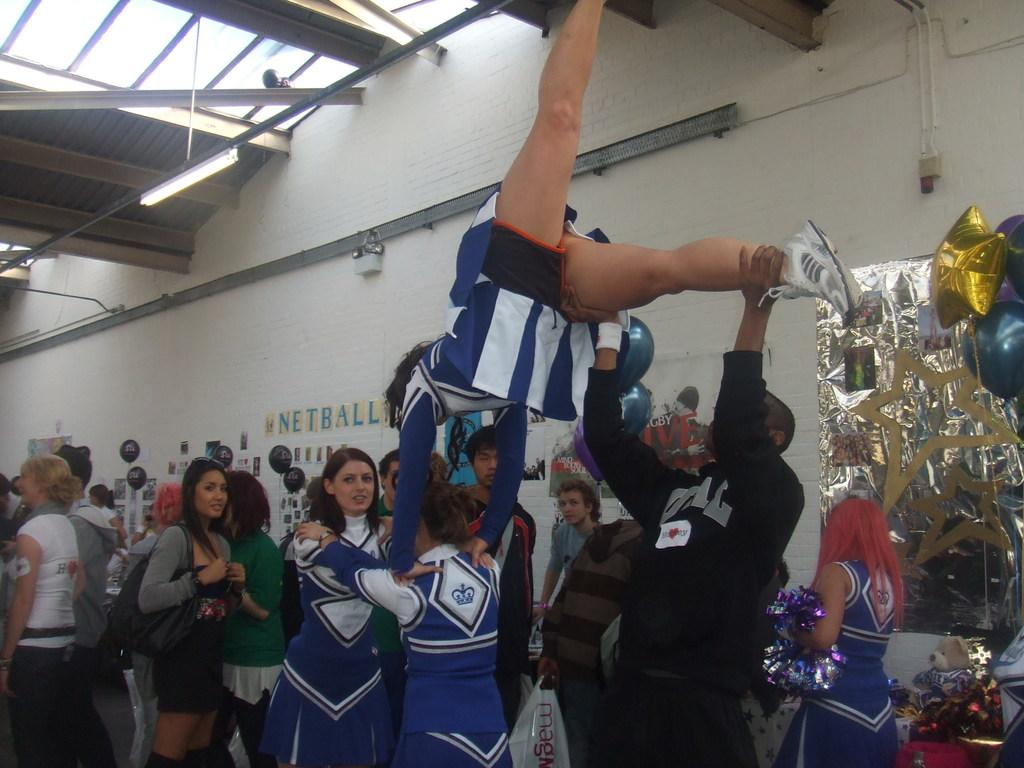How many people are in the image? There is a group of people in the image. What is one person doing with another person in the image? One person is holding another person in the image. What decorative items can be seen in the image? There are colorful balloons and stickers attached to the wall in the image. Where is the jail located in the image? There is no jail present in the image. How many legs are visible in the image? The number of legs visible in the image cannot be determined from the provided facts. 